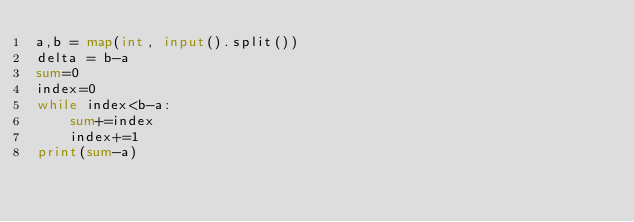<code> <loc_0><loc_0><loc_500><loc_500><_Python_>a,b = map(int, input().split())
delta = b-a
sum=0
index=0
while index<b-a:
    sum+=index
    index+=1
print(sum-a)   
</code> 